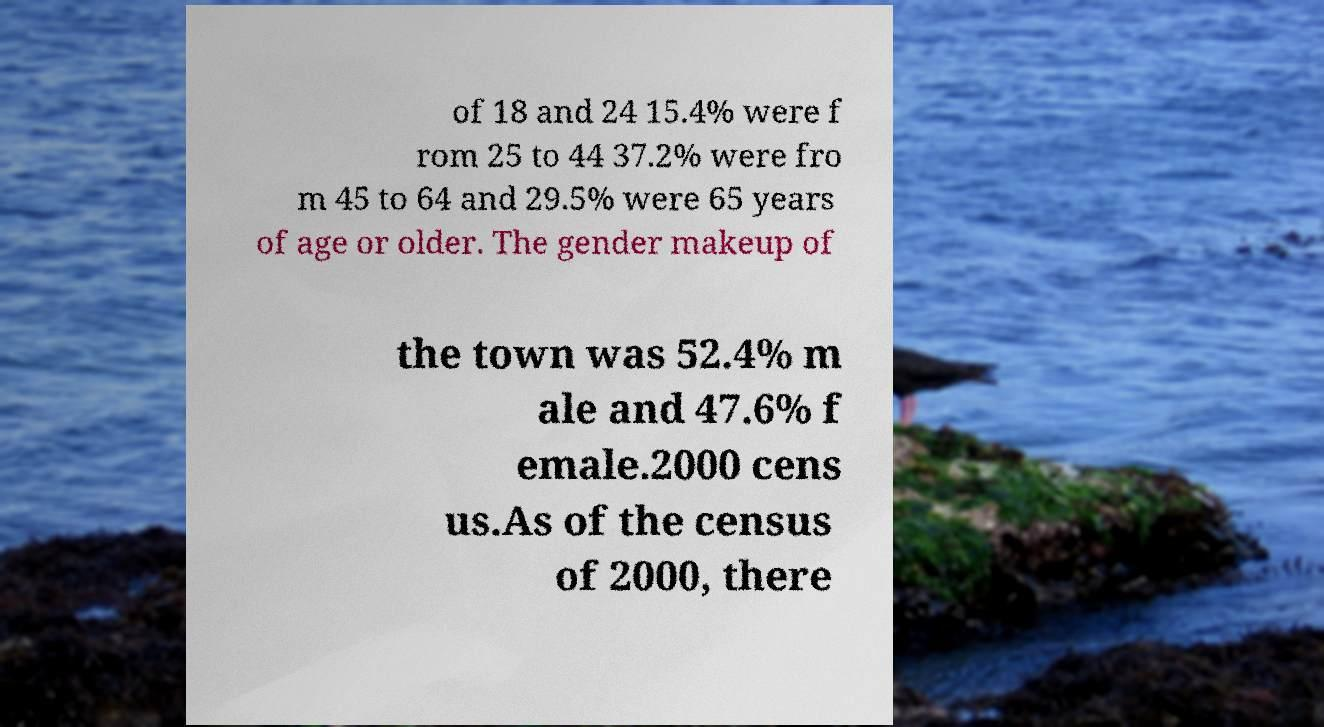Can you read and provide the text displayed in the image?This photo seems to have some interesting text. Can you extract and type it out for me? of 18 and 24 15.4% were f rom 25 to 44 37.2% were fro m 45 to 64 and 29.5% were 65 years of age or older. The gender makeup of the town was 52.4% m ale and 47.6% f emale.2000 cens us.As of the census of 2000, there 